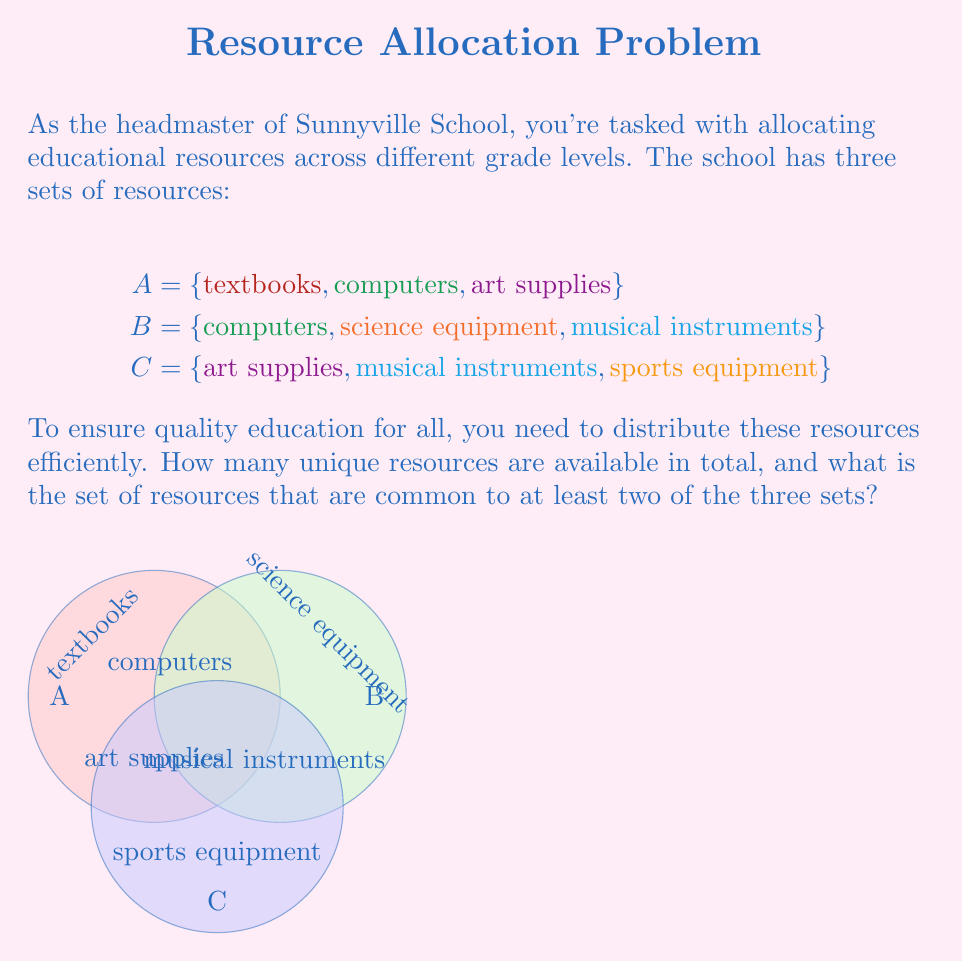Solve this math problem. Let's approach this step-by-step using set theory:

1) First, let's find the total number of unique resources. This is equivalent to finding the cardinality of the union of all three sets:

   $|A \cup B \cup C|$

2) We can list out all unique elements:
   $\{\text{textbooks}, \text{computers}, \text{art supplies}, \text{science equipment}, \text{musical instruments}, \text{sports equipment}\}$

3) Counting these, we get 6 unique resources.

4) Now, for the second part of the question, we need to find the elements that are in at least two of the three sets. This can be represented as:

   $(A \cap B) \cup (B \cap C) \cup (A \cap C)$

5) Let's break this down:
   $A \cap B = \{\text{computers}\}$
   $B \cap C = \{\text{musical instruments}\}$
   $A \cap C = \{\text{art supplies}\}$

6) Taking the union of these intersections:
   $(A \cap B) \cup (B \cap C) \cup (A \cap C) = \{\text{computers}, \text{musical instruments}, \text{art supplies}\}$

Therefore, there are 3 resources that are common to at least two of the three sets.
Answer: 6 unique resources; $\{\text{computers}, \text{musical instruments}, \text{art supplies}\}$ 